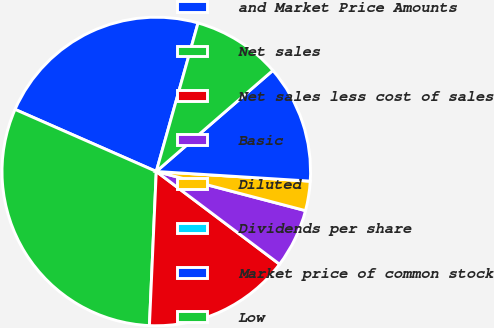Convert chart. <chart><loc_0><loc_0><loc_500><loc_500><pie_chart><fcel>and Market Price Amounts<fcel>Net sales<fcel>Net sales less cost of sales<fcel>Basic<fcel>Diluted<fcel>Dividends per share<fcel>Market price of common stock<fcel>Low<nl><fcel>22.77%<fcel>30.88%<fcel>15.44%<fcel>6.18%<fcel>3.09%<fcel>0.0%<fcel>12.36%<fcel>9.27%<nl></chart> 